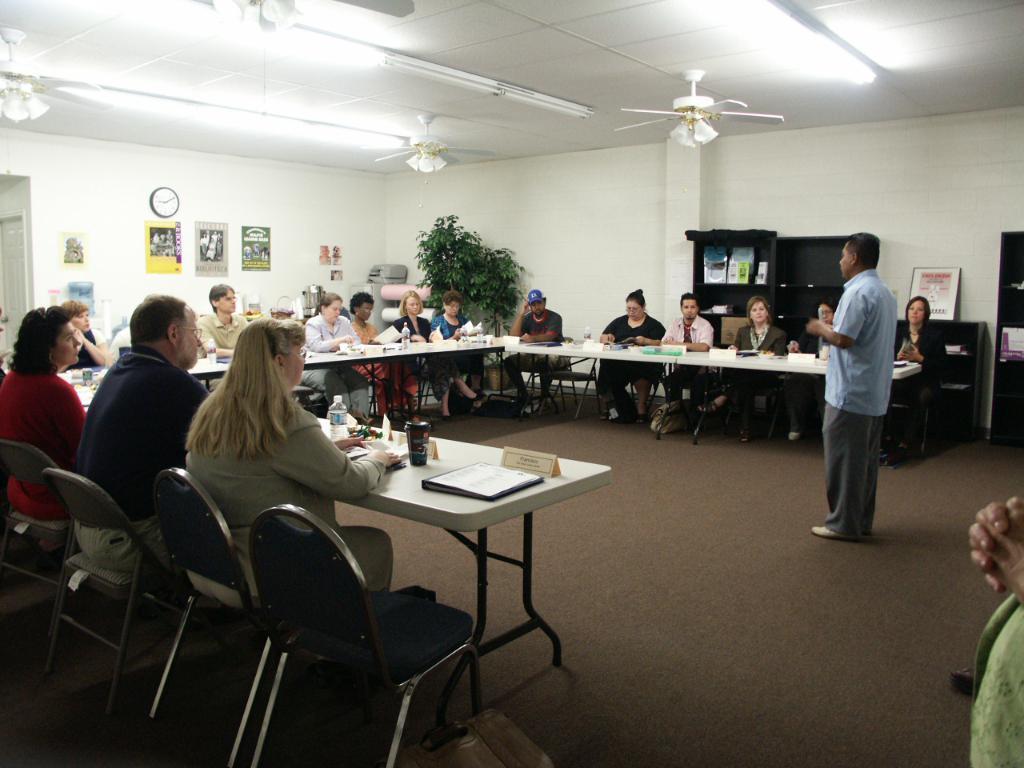How would you summarize this image in a sentence or two? In this image I can see number of people where a man is standing and rest all are sitting on chairs. On these tables I can see few bottles and cups. 